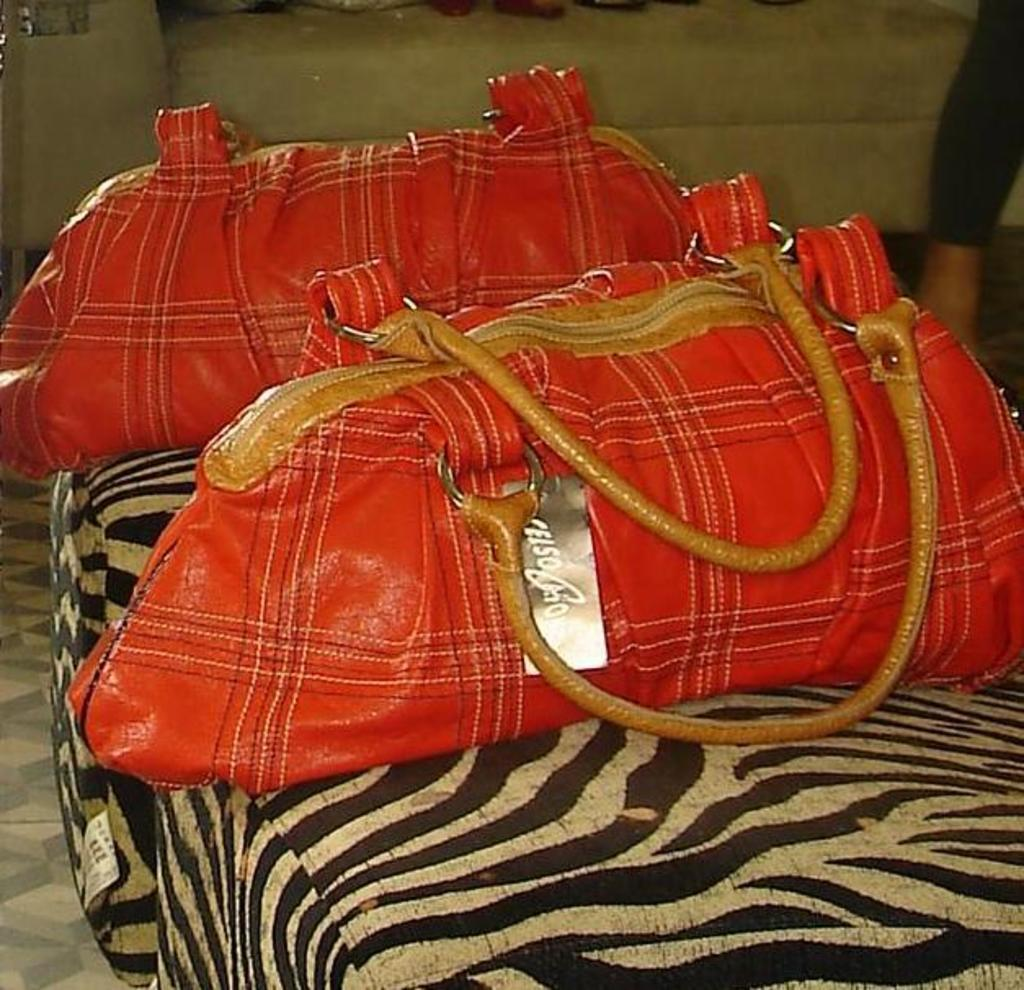What color are the bags that can be seen in the image? The bags are red. How many red bags are visible in the image? There are two red bags in the image. Where are the red bags located? The red bags are placed on a chair. What other furniture can be seen in the background of the image? There is a sofa in the background of the image. What type of line can be seen connecting the two red bags in the image? There is no line connecting the two red bags in the image. 